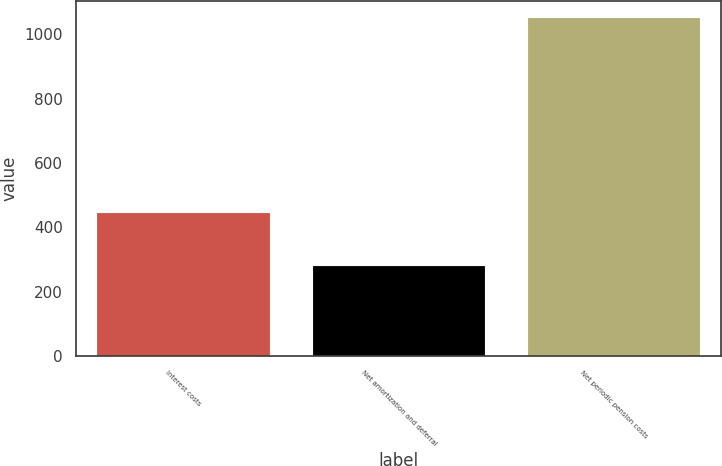Convert chart to OTSL. <chart><loc_0><loc_0><loc_500><loc_500><bar_chart><fcel>Interest costs<fcel>Net amortization and deferral<fcel>Net periodic pension costs<nl><fcel>444<fcel>279<fcel>1052<nl></chart> 